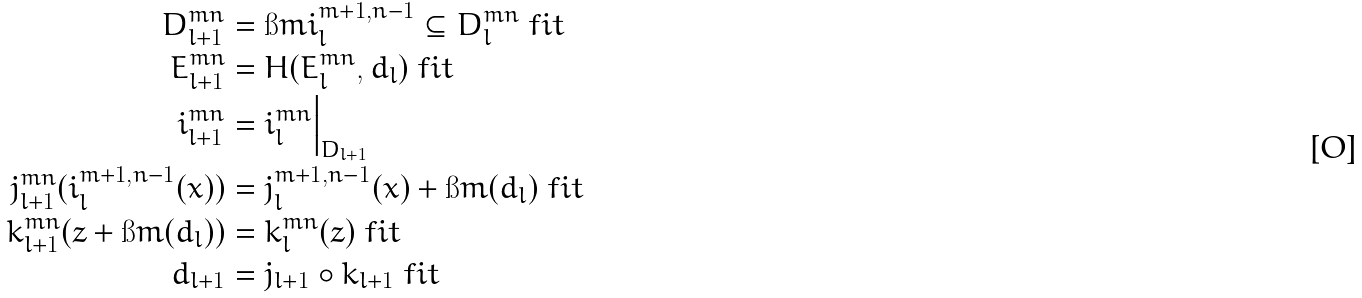Convert formula to latex. <formula><loc_0><loc_0><loc_500><loc_500>D _ { l + 1 } ^ { m n } & = \i m { i _ { l } ^ { m + 1 , n - 1 } } \subseteq D _ { l } ^ { m n } \ f i t \\ E _ { l + 1 } ^ { m n } & = H ( E ^ { m n } _ { l } , d _ { l } ) \ f i t \\ i _ { l + 1 } ^ { m n } & = i _ { l } ^ { m n } \Big | _ { D _ { l + 1 } } \\ j _ { l + 1 } ^ { m n } ( i _ { l } ^ { m + 1 , n - 1 } ( x ) ) & = j _ { l } ^ { m + 1 , n - 1 } ( x ) + \i m ( d _ { l } ) \ f i t \\ k _ { l + 1 } ^ { m n } ( z + \i m ( d _ { l } ) ) & = k _ { l } ^ { m n } ( z ) \ f i t \\ d _ { l + 1 } & = j _ { l + 1 } \circ k _ { l + 1 } \ f i t</formula> 